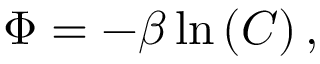Convert formula to latex. <formula><loc_0><loc_0><loc_500><loc_500>\Phi = - \beta \ln \left ( C \right ) ,</formula> 